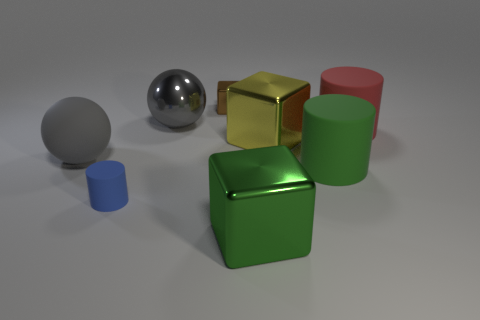Add 2 metal balls. How many objects exist? 10 Subtract all cylinders. How many objects are left? 5 Add 2 small rubber cylinders. How many small rubber cylinders are left? 3 Add 5 yellow metallic blocks. How many yellow metallic blocks exist? 6 Subtract 0 gray blocks. How many objects are left? 8 Subtract all tiny metallic things. Subtract all large yellow metallic cubes. How many objects are left? 6 